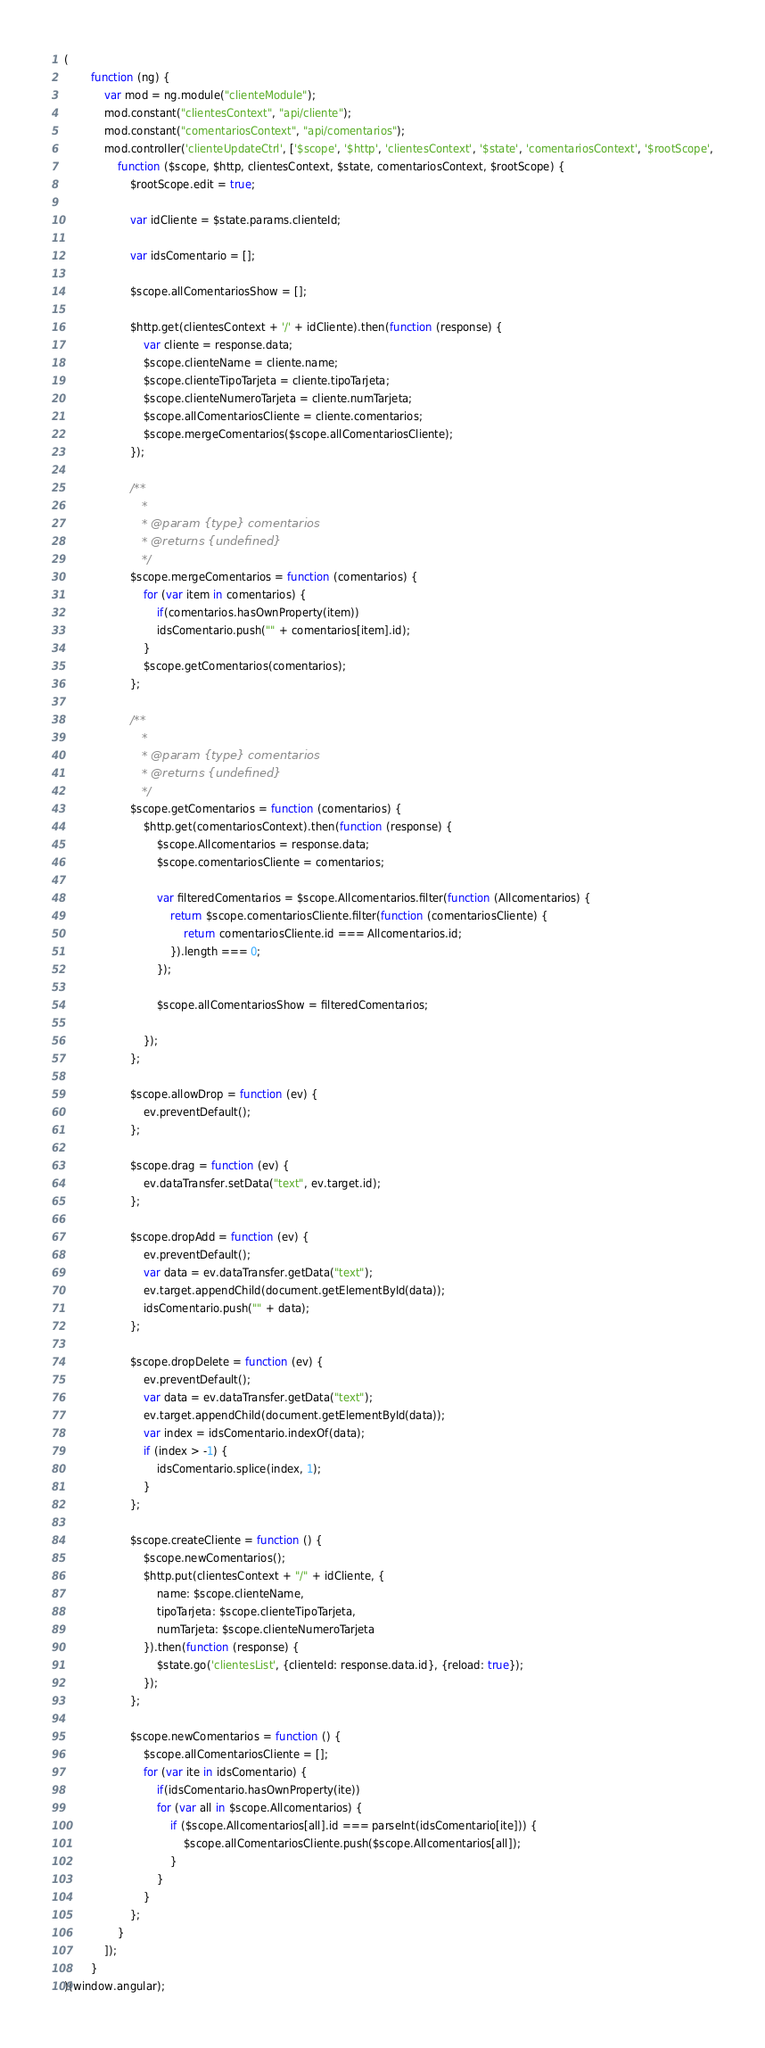Convert code to text. <code><loc_0><loc_0><loc_500><loc_500><_JavaScript_>(
        function (ng) {
            var mod = ng.module("clienteModule");
            mod.constant("clientesContext", "api/cliente");
            mod.constant("comentariosContext", "api/comentarios");
            mod.controller('clienteUpdateCtrl', ['$scope', '$http', 'clientesContext', '$state', 'comentariosContext', '$rootScope',
                function ($scope, $http, clientesContext, $state, comentariosContext, $rootScope) {
                    $rootScope.edit = true;

                    var idCliente = $state.params.clienteId;

                    var idsComentario = [];

                    $scope.allComentariosShow = [];

                    $http.get(clientesContext + '/' + idCliente).then(function (response) {
                        var cliente = response.data;
                        $scope.clienteName = cliente.name;
                        $scope.clienteTipoTarjeta = cliente.tipoTarjeta;
                        $scope.clienteNumeroTarjeta = cliente.numTarjeta;
                        $scope.allComentariosCliente = cliente.comentarios;
                        $scope.mergeComentarios($scope.allComentariosCliente);
                    });

                    /**
                     * 
                     * @param {type} comentarios
                     * @returns {undefined}
                     */
                    $scope.mergeComentarios = function (comentarios) {
                        for (var item in comentarios) {
                            if(comentarios.hasOwnProperty(item))
                            idsComentario.push("" + comentarios[item].id);
                        }
                        $scope.getComentarios(comentarios);
                    };

                    /**
                     * 
                     * @param {type} comentarios
                     * @returns {undefined}
                     */
                    $scope.getComentarios = function (comentarios) {
                        $http.get(comentariosContext).then(function (response) {
                            $scope.Allcomentarios = response.data;
                            $scope.comentariosCliente = comentarios;

                            var filteredComentarios = $scope.Allcomentarios.filter(function (Allcomentarios) {
                                return $scope.comentariosCliente.filter(function (comentariosCliente) {
                                    return comentariosCliente.id === Allcomentarios.id;
                                }).length === 0;
                            });

                            $scope.allComentariosShow = filteredComentarios;

                        });
                    };
                                      
                    $scope.allowDrop = function (ev) {
                        ev.preventDefault();
                    };

                    $scope.drag = function (ev) {
                        ev.dataTransfer.setData("text", ev.target.id);
                    };

                    $scope.dropAdd = function (ev) {
                        ev.preventDefault();
                        var data = ev.dataTransfer.getData("text");
                        ev.target.appendChild(document.getElementById(data));
                        idsComentario.push("" + data);
                    };

                    $scope.dropDelete = function (ev) {
                        ev.preventDefault();
                        var data = ev.dataTransfer.getData("text");
                        ev.target.appendChild(document.getElementById(data));
                        var index = idsComentario.indexOf(data);
                        if (index > -1) {
                            idsComentario.splice(index, 1);
                        }
                    };

                    $scope.createCliente = function () {
                        $scope.newComentarios();
                        $http.put(clientesContext + "/" + idCliente, {
                            name: $scope.clienteName,
                            tipoTarjeta: $scope.clienteTipoTarjeta,
                            numTarjeta: $scope.clienteNumeroTarjeta
                        }).then(function (response) {
                            $state.go('clientesList', {clienteId: response.data.id}, {reload: true});
                        });
                    };

                    $scope.newComentarios = function () {
                        $scope.allComentariosCliente = [];
                        for (var ite in idsComentario) {
                            if(idsComentario.hasOwnProperty(ite))
                            for (var all in $scope.Allcomentarios) {
                                if ($scope.Allcomentarios[all].id === parseInt(idsComentario[ite])) {
                                    $scope.allComentariosCliente.push($scope.Allcomentarios[all]);
                                }
                            }
                        }
                    };
                }
            ]);
        }
)(window.angular);</code> 